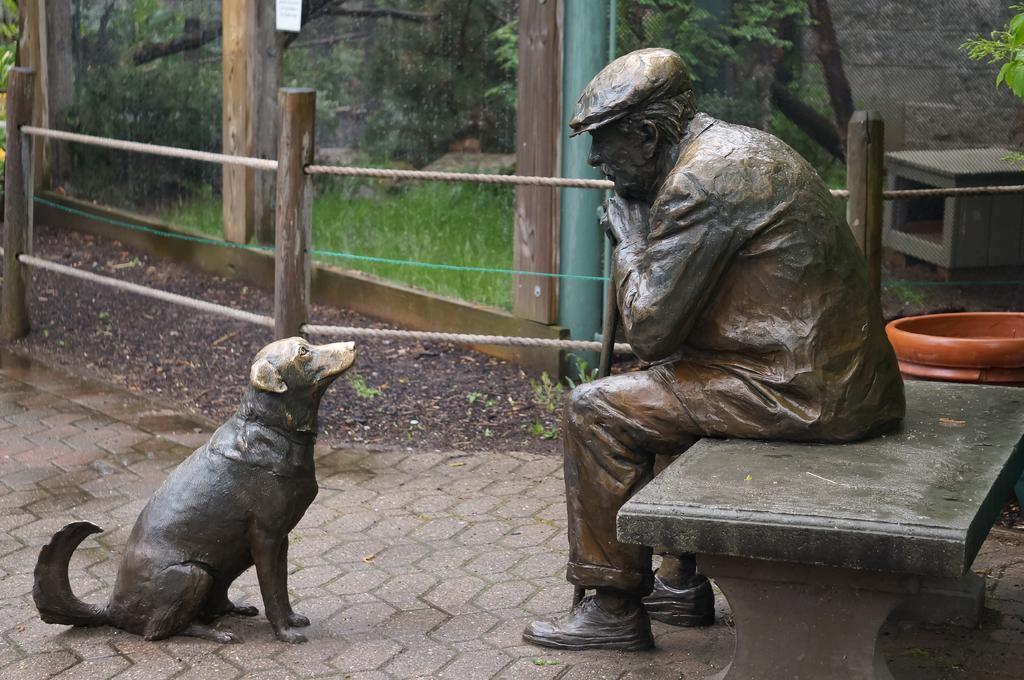In one or two sentences, can you explain what this image depicts? In this picture there are two statues, one statue is a man sitting on the bench and another statue is a dog sitting in front of the man statue and behind them there are trees and building. 